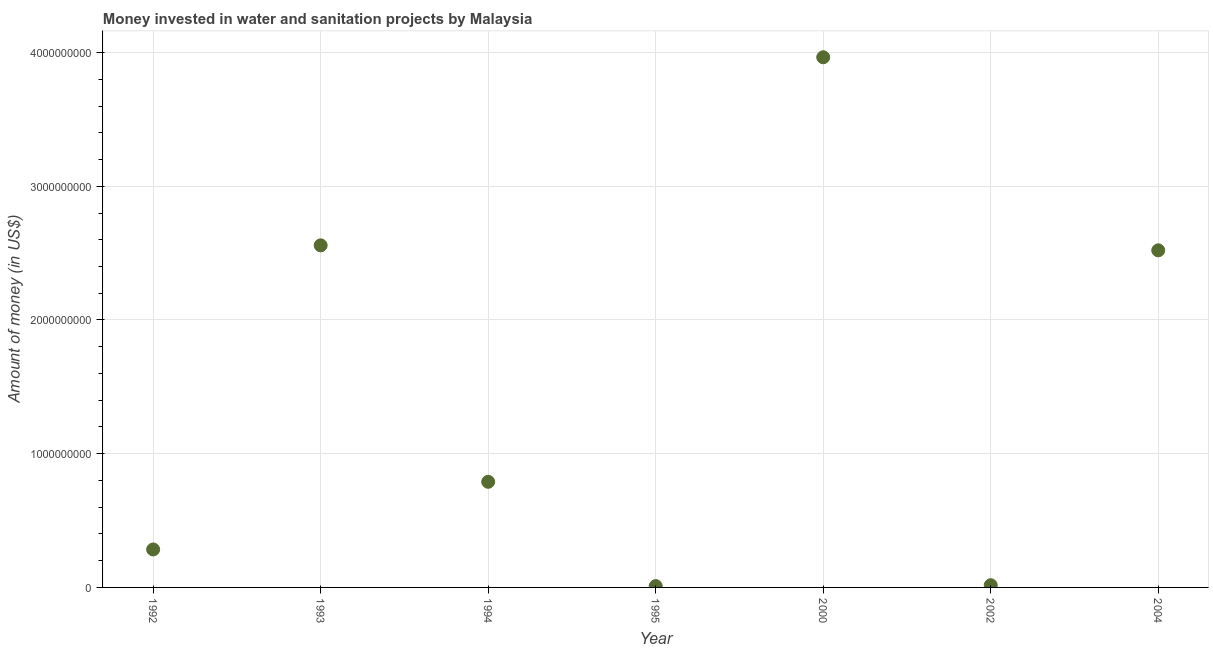What is the investment in 1994?
Make the answer very short. 7.90e+08. Across all years, what is the maximum investment?
Your answer should be compact. 3.96e+09. Across all years, what is the minimum investment?
Your answer should be very brief. 1.00e+07. What is the sum of the investment?
Offer a very short reply. 1.01e+1. What is the difference between the investment in 1993 and 2004?
Make the answer very short. 3.72e+07. What is the average investment per year?
Offer a very short reply. 1.45e+09. What is the median investment?
Give a very brief answer. 7.90e+08. Do a majority of the years between 2000 and 2002 (inclusive) have investment greater than 2600000000 US$?
Your answer should be compact. No. What is the ratio of the investment in 1992 to that in 2004?
Offer a very short reply. 0.11. Is the investment in 1993 less than that in 2002?
Provide a short and direct response. No. What is the difference between the highest and the second highest investment?
Your answer should be very brief. 1.41e+09. What is the difference between the highest and the lowest investment?
Offer a very short reply. 3.95e+09. Does the investment monotonically increase over the years?
Keep it short and to the point. No. How many years are there in the graph?
Your answer should be very brief. 7. What is the difference between two consecutive major ticks on the Y-axis?
Offer a terse response. 1.00e+09. Are the values on the major ticks of Y-axis written in scientific E-notation?
Provide a succinct answer. No. Does the graph contain grids?
Offer a very short reply. Yes. What is the title of the graph?
Keep it short and to the point. Money invested in water and sanitation projects by Malaysia. What is the label or title of the Y-axis?
Your response must be concise. Amount of money (in US$). What is the Amount of money (in US$) in 1992?
Your answer should be very brief. 2.84e+08. What is the Amount of money (in US$) in 1993?
Provide a succinct answer. 2.56e+09. What is the Amount of money (in US$) in 1994?
Your response must be concise. 7.90e+08. What is the Amount of money (in US$) in 2000?
Give a very brief answer. 3.96e+09. What is the Amount of money (in US$) in 2002?
Give a very brief answer. 1.64e+07. What is the Amount of money (in US$) in 2004?
Ensure brevity in your answer.  2.52e+09. What is the difference between the Amount of money (in US$) in 1992 and 1993?
Provide a succinct answer. -2.27e+09. What is the difference between the Amount of money (in US$) in 1992 and 1994?
Provide a succinct answer. -5.06e+08. What is the difference between the Amount of money (in US$) in 1992 and 1995?
Offer a terse response. 2.74e+08. What is the difference between the Amount of money (in US$) in 1992 and 2000?
Provide a short and direct response. -3.68e+09. What is the difference between the Amount of money (in US$) in 1992 and 2002?
Keep it short and to the point. 2.68e+08. What is the difference between the Amount of money (in US$) in 1992 and 2004?
Your response must be concise. -2.24e+09. What is the difference between the Amount of money (in US$) in 1993 and 1994?
Your response must be concise. 1.77e+09. What is the difference between the Amount of money (in US$) in 1993 and 1995?
Your response must be concise. 2.55e+09. What is the difference between the Amount of money (in US$) in 1993 and 2000?
Make the answer very short. -1.41e+09. What is the difference between the Amount of money (in US$) in 1993 and 2002?
Ensure brevity in your answer.  2.54e+09. What is the difference between the Amount of money (in US$) in 1993 and 2004?
Your response must be concise. 3.72e+07. What is the difference between the Amount of money (in US$) in 1994 and 1995?
Your answer should be compact. 7.80e+08. What is the difference between the Amount of money (in US$) in 1994 and 2000?
Ensure brevity in your answer.  -3.17e+09. What is the difference between the Amount of money (in US$) in 1994 and 2002?
Offer a very short reply. 7.74e+08. What is the difference between the Amount of money (in US$) in 1994 and 2004?
Your answer should be very brief. -1.73e+09. What is the difference between the Amount of money (in US$) in 1995 and 2000?
Keep it short and to the point. -3.95e+09. What is the difference between the Amount of money (in US$) in 1995 and 2002?
Offer a very short reply. -6.40e+06. What is the difference between the Amount of money (in US$) in 1995 and 2004?
Your answer should be compact. -2.51e+09. What is the difference between the Amount of money (in US$) in 2000 and 2002?
Your answer should be very brief. 3.95e+09. What is the difference between the Amount of money (in US$) in 2000 and 2004?
Offer a terse response. 1.44e+09. What is the difference between the Amount of money (in US$) in 2002 and 2004?
Your answer should be compact. -2.50e+09. What is the ratio of the Amount of money (in US$) in 1992 to that in 1993?
Ensure brevity in your answer.  0.11. What is the ratio of the Amount of money (in US$) in 1992 to that in 1994?
Ensure brevity in your answer.  0.36. What is the ratio of the Amount of money (in US$) in 1992 to that in 1995?
Provide a succinct answer. 28.4. What is the ratio of the Amount of money (in US$) in 1992 to that in 2000?
Offer a terse response. 0.07. What is the ratio of the Amount of money (in US$) in 1992 to that in 2002?
Your response must be concise. 17.32. What is the ratio of the Amount of money (in US$) in 1992 to that in 2004?
Provide a short and direct response. 0.11. What is the ratio of the Amount of money (in US$) in 1993 to that in 1994?
Provide a succinct answer. 3.24. What is the ratio of the Amount of money (in US$) in 1993 to that in 1995?
Provide a short and direct response. 255.82. What is the ratio of the Amount of money (in US$) in 1993 to that in 2000?
Your answer should be compact. 0.65. What is the ratio of the Amount of money (in US$) in 1993 to that in 2002?
Provide a short and direct response. 155.99. What is the ratio of the Amount of money (in US$) in 1993 to that in 2004?
Provide a succinct answer. 1.01. What is the ratio of the Amount of money (in US$) in 1994 to that in 1995?
Your response must be concise. 79. What is the ratio of the Amount of money (in US$) in 1994 to that in 2000?
Make the answer very short. 0.2. What is the ratio of the Amount of money (in US$) in 1994 to that in 2002?
Provide a short and direct response. 48.17. What is the ratio of the Amount of money (in US$) in 1994 to that in 2004?
Your response must be concise. 0.31. What is the ratio of the Amount of money (in US$) in 1995 to that in 2000?
Provide a succinct answer. 0. What is the ratio of the Amount of money (in US$) in 1995 to that in 2002?
Make the answer very short. 0.61. What is the ratio of the Amount of money (in US$) in 1995 to that in 2004?
Offer a terse response. 0. What is the ratio of the Amount of money (in US$) in 2000 to that in 2002?
Your answer should be compact. 241.76. What is the ratio of the Amount of money (in US$) in 2000 to that in 2004?
Your answer should be very brief. 1.57. What is the ratio of the Amount of money (in US$) in 2002 to that in 2004?
Provide a short and direct response. 0.01. 